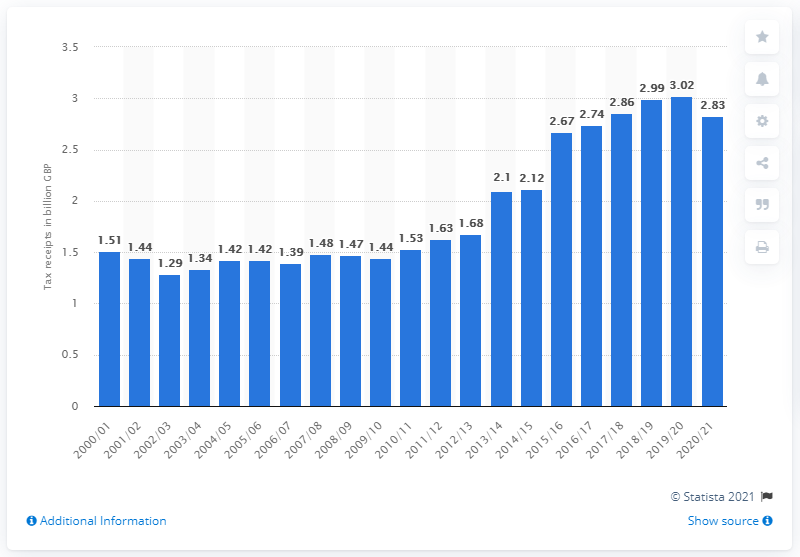Specify some key components in this picture. The amount of betting and gaming tax receipts in the previous year was 3.02. 